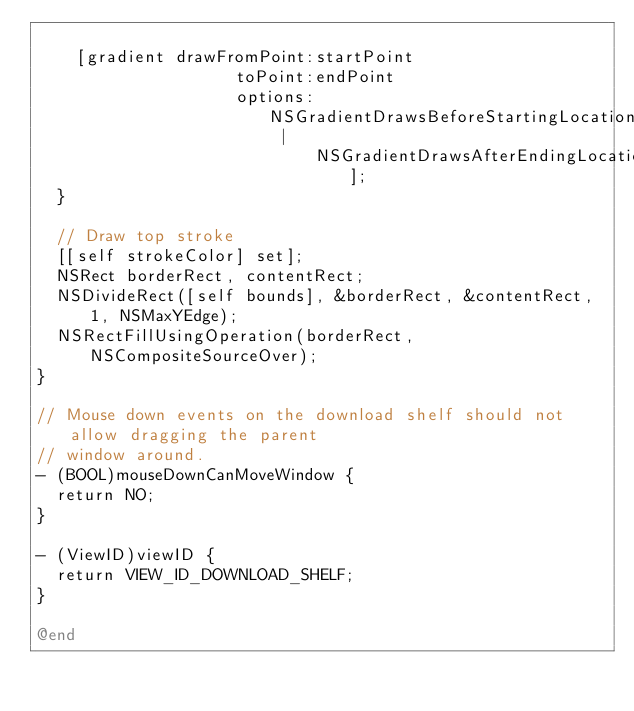<code> <loc_0><loc_0><loc_500><loc_500><_ObjectiveC_>
    [gradient drawFromPoint:startPoint
                    toPoint:endPoint
                    options:NSGradientDrawsBeforeStartingLocation |
                            NSGradientDrawsAfterEndingLocation];
  }

  // Draw top stroke
  [[self strokeColor] set];
  NSRect borderRect, contentRect;
  NSDivideRect([self bounds], &borderRect, &contentRect, 1, NSMaxYEdge);
  NSRectFillUsingOperation(borderRect, NSCompositeSourceOver);
}

// Mouse down events on the download shelf should not allow dragging the parent
// window around.
- (BOOL)mouseDownCanMoveWindow {
  return NO;
}

- (ViewID)viewID {
  return VIEW_ID_DOWNLOAD_SHELF;
}

@end
</code> 